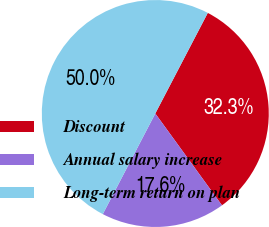Convert chart to OTSL. <chart><loc_0><loc_0><loc_500><loc_500><pie_chart><fcel>Discount<fcel>Annual salary increase<fcel>Long-term return on plan<nl><fcel>32.35%<fcel>17.65%<fcel>50.0%<nl></chart> 